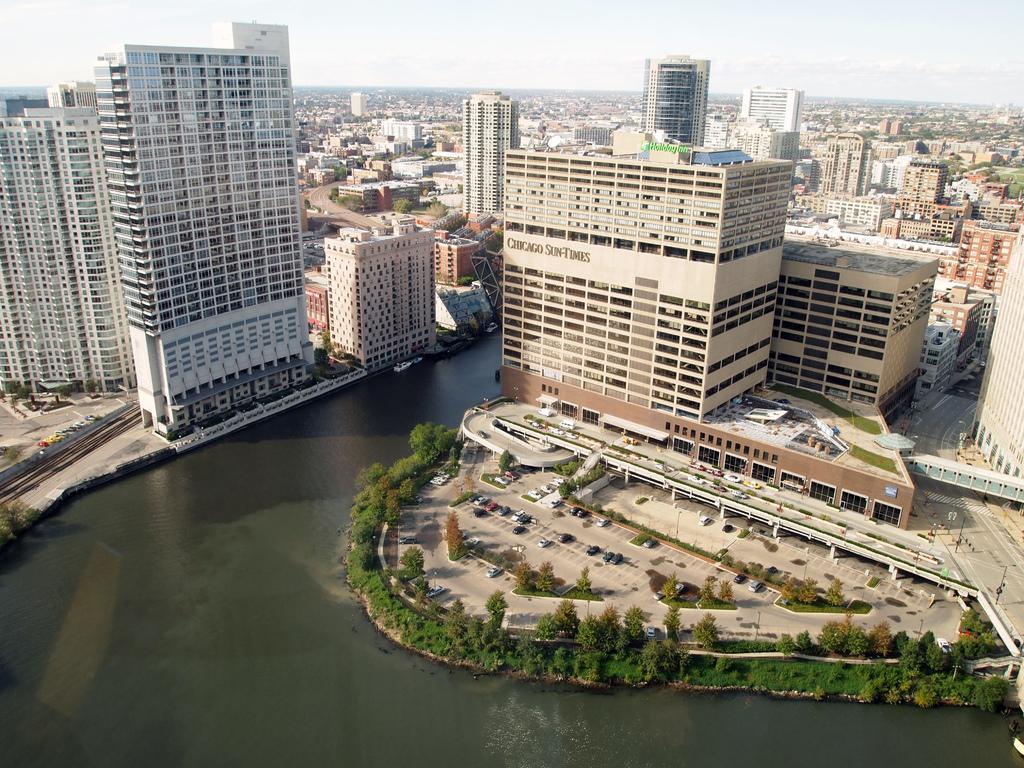Can you describe this image briefly? In this image I can see number of buildings, number of trees, number of vehicles, few roads and here I can see water. 